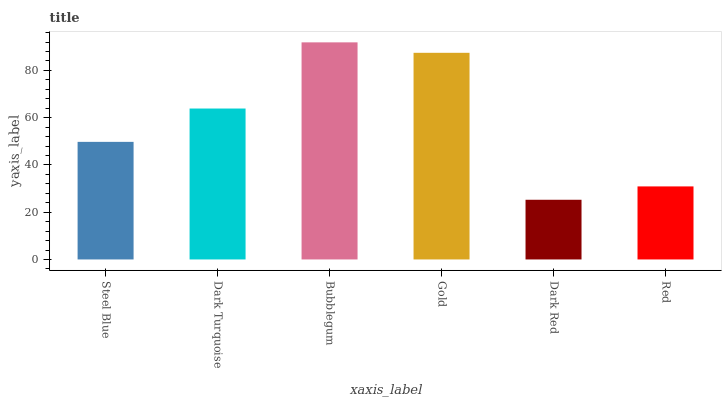Is Dark Red the minimum?
Answer yes or no. Yes. Is Bubblegum the maximum?
Answer yes or no. Yes. Is Dark Turquoise the minimum?
Answer yes or no. No. Is Dark Turquoise the maximum?
Answer yes or no. No. Is Dark Turquoise greater than Steel Blue?
Answer yes or no. Yes. Is Steel Blue less than Dark Turquoise?
Answer yes or no. Yes. Is Steel Blue greater than Dark Turquoise?
Answer yes or no. No. Is Dark Turquoise less than Steel Blue?
Answer yes or no. No. Is Dark Turquoise the high median?
Answer yes or no. Yes. Is Steel Blue the low median?
Answer yes or no. Yes. Is Red the high median?
Answer yes or no. No. Is Dark Red the low median?
Answer yes or no. No. 